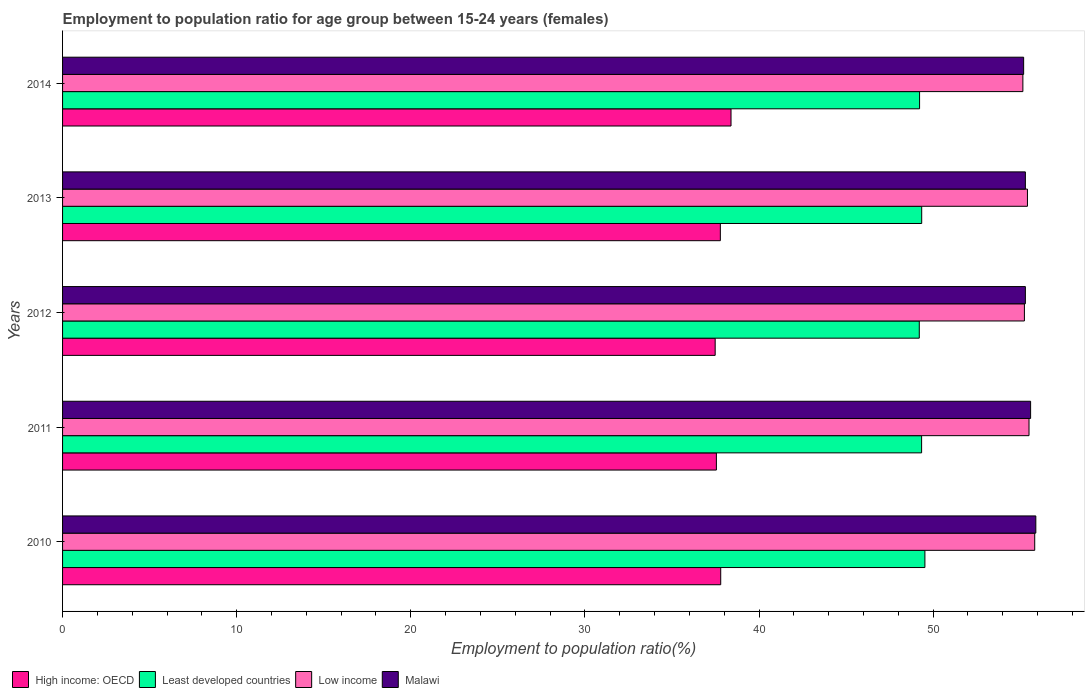How many groups of bars are there?
Ensure brevity in your answer.  5. Are the number of bars per tick equal to the number of legend labels?
Provide a short and direct response. Yes. How many bars are there on the 2nd tick from the top?
Your answer should be very brief. 4. How many bars are there on the 5th tick from the bottom?
Provide a succinct answer. 4. In how many cases, is the number of bars for a given year not equal to the number of legend labels?
Your answer should be very brief. 0. What is the employment to population ratio in Low income in 2013?
Provide a short and direct response. 55.42. Across all years, what is the maximum employment to population ratio in High income: OECD?
Your response must be concise. 38.39. Across all years, what is the minimum employment to population ratio in High income: OECD?
Ensure brevity in your answer.  37.48. In which year was the employment to population ratio in Low income maximum?
Your answer should be very brief. 2010. What is the total employment to population ratio in Low income in the graph?
Your answer should be compact. 277.16. What is the difference between the employment to population ratio in Least developed countries in 2011 and that in 2014?
Give a very brief answer. 0.12. What is the difference between the employment to population ratio in Low income in 2014 and the employment to population ratio in Least developed countries in 2012?
Your answer should be compact. 5.95. What is the average employment to population ratio in Low income per year?
Provide a succinct answer. 55.43. In the year 2014, what is the difference between the employment to population ratio in High income: OECD and employment to population ratio in Malawi?
Offer a terse response. -16.81. In how many years, is the employment to population ratio in Least developed countries greater than 24 %?
Give a very brief answer. 5. What is the ratio of the employment to population ratio in Low income in 2012 to that in 2013?
Offer a terse response. 1. Is the employment to population ratio in Malawi in 2013 less than that in 2014?
Your answer should be very brief. No. What is the difference between the highest and the second highest employment to population ratio in High income: OECD?
Offer a very short reply. 0.59. What is the difference between the highest and the lowest employment to population ratio in Least developed countries?
Offer a terse response. 0.32. Is the sum of the employment to population ratio in Low income in 2012 and 2013 greater than the maximum employment to population ratio in Malawi across all years?
Provide a short and direct response. Yes. Is it the case that in every year, the sum of the employment to population ratio in Least developed countries and employment to population ratio in High income: OECD is greater than the sum of employment to population ratio in Low income and employment to population ratio in Malawi?
Your answer should be compact. No. What does the 4th bar from the top in 2010 represents?
Keep it short and to the point. High income: OECD. What does the 4th bar from the bottom in 2013 represents?
Offer a very short reply. Malawi. Is it the case that in every year, the sum of the employment to population ratio in High income: OECD and employment to population ratio in Low income is greater than the employment to population ratio in Malawi?
Your answer should be compact. Yes. Are all the bars in the graph horizontal?
Your answer should be compact. Yes. What is the difference between two consecutive major ticks on the X-axis?
Your answer should be very brief. 10. Does the graph contain any zero values?
Ensure brevity in your answer.  No. Does the graph contain grids?
Provide a short and direct response. No. Where does the legend appear in the graph?
Make the answer very short. Bottom left. How are the legend labels stacked?
Keep it short and to the point. Horizontal. What is the title of the graph?
Your response must be concise. Employment to population ratio for age group between 15-24 years (females). What is the Employment to population ratio(%) in High income: OECD in 2010?
Ensure brevity in your answer.  37.8. What is the Employment to population ratio(%) in Least developed countries in 2010?
Give a very brief answer. 49.53. What is the Employment to population ratio(%) in Low income in 2010?
Offer a very short reply. 55.84. What is the Employment to population ratio(%) of Malawi in 2010?
Give a very brief answer. 55.9. What is the Employment to population ratio(%) in High income: OECD in 2011?
Provide a short and direct response. 37.55. What is the Employment to population ratio(%) in Least developed countries in 2011?
Your answer should be very brief. 49.34. What is the Employment to population ratio(%) in Low income in 2011?
Your response must be concise. 55.51. What is the Employment to population ratio(%) of Malawi in 2011?
Keep it short and to the point. 55.6. What is the Employment to population ratio(%) in High income: OECD in 2012?
Your answer should be very brief. 37.48. What is the Employment to population ratio(%) of Least developed countries in 2012?
Your response must be concise. 49.21. What is the Employment to population ratio(%) in Low income in 2012?
Offer a terse response. 55.24. What is the Employment to population ratio(%) of Malawi in 2012?
Provide a short and direct response. 55.3. What is the Employment to population ratio(%) in High income: OECD in 2013?
Your answer should be very brief. 37.78. What is the Employment to population ratio(%) in Least developed countries in 2013?
Give a very brief answer. 49.35. What is the Employment to population ratio(%) in Low income in 2013?
Provide a succinct answer. 55.42. What is the Employment to population ratio(%) of Malawi in 2013?
Offer a very short reply. 55.3. What is the Employment to population ratio(%) in High income: OECD in 2014?
Offer a very short reply. 38.39. What is the Employment to population ratio(%) of Least developed countries in 2014?
Offer a terse response. 49.22. What is the Employment to population ratio(%) in Low income in 2014?
Ensure brevity in your answer.  55.16. What is the Employment to population ratio(%) of Malawi in 2014?
Ensure brevity in your answer.  55.2. Across all years, what is the maximum Employment to population ratio(%) in High income: OECD?
Provide a short and direct response. 38.39. Across all years, what is the maximum Employment to population ratio(%) of Least developed countries?
Make the answer very short. 49.53. Across all years, what is the maximum Employment to population ratio(%) in Low income?
Make the answer very short. 55.84. Across all years, what is the maximum Employment to population ratio(%) of Malawi?
Make the answer very short. 55.9. Across all years, what is the minimum Employment to population ratio(%) in High income: OECD?
Offer a very short reply. 37.48. Across all years, what is the minimum Employment to population ratio(%) in Least developed countries?
Ensure brevity in your answer.  49.21. Across all years, what is the minimum Employment to population ratio(%) of Low income?
Offer a very short reply. 55.16. Across all years, what is the minimum Employment to population ratio(%) in Malawi?
Provide a succinct answer. 55.2. What is the total Employment to population ratio(%) of High income: OECD in the graph?
Offer a very short reply. 189.01. What is the total Employment to population ratio(%) of Least developed countries in the graph?
Offer a terse response. 246.64. What is the total Employment to population ratio(%) in Low income in the graph?
Ensure brevity in your answer.  277.16. What is the total Employment to population ratio(%) in Malawi in the graph?
Your answer should be compact. 277.3. What is the difference between the Employment to population ratio(%) of High income: OECD in 2010 and that in 2011?
Make the answer very short. 0.25. What is the difference between the Employment to population ratio(%) of Least developed countries in 2010 and that in 2011?
Offer a terse response. 0.19. What is the difference between the Employment to population ratio(%) in Low income in 2010 and that in 2011?
Give a very brief answer. 0.33. What is the difference between the Employment to population ratio(%) of Malawi in 2010 and that in 2011?
Provide a short and direct response. 0.3. What is the difference between the Employment to population ratio(%) in High income: OECD in 2010 and that in 2012?
Your response must be concise. 0.32. What is the difference between the Employment to population ratio(%) in Least developed countries in 2010 and that in 2012?
Give a very brief answer. 0.32. What is the difference between the Employment to population ratio(%) of Low income in 2010 and that in 2012?
Your answer should be compact. 0.59. What is the difference between the Employment to population ratio(%) of Malawi in 2010 and that in 2012?
Provide a short and direct response. 0.6. What is the difference between the Employment to population ratio(%) in High income: OECD in 2010 and that in 2013?
Make the answer very short. 0.02. What is the difference between the Employment to population ratio(%) of Least developed countries in 2010 and that in 2013?
Give a very brief answer. 0.18. What is the difference between the Employment to population ratio(%) in Low income in 2010 and that in 2013?
Your response must be concise. 0.42. What is the difference between the Employment to population ratio(%) of Malawi in 2010 and that in 2013?
Your answer should be compact. 0.6. What is the difference between the Employment to population ratio(%) of High income: OECD in 2010 and that in 2014?
Your response must be concise. -0.59. What is the difference between the Employment to population ratio(%) in Least developed countries in 2010 and that in 2014?
Your response must be concise. 0.31. What is the difference between the Employment to population ratio(%) in Low income in 2010 and that in 2014?
Provide a succinct answer. 0.68. What is the difference between the Employment to population ratio(%) of High income: OECD in 2011 and that in 2012?
Your response must be concise. 0.07. What is the difference between the Employment to population ratio(%) in Least developed countries in 2011 and that in 2012?
Your answer should be very brief. 0.13. What is the difference between the Employment to population ratio(%) of Low income in 2011 and that in 2012?
Your answer should be compact. 0.27. What is the difference between the Employment to population ratio(%) of Malawi in 2011 and that in 2012?
Offer a very short reply. 0.3. What is the difference between the Employment to population ratio(%) in High income: OECD in 2011 and that in 2013?
Ensure brevity in your answer.  -0.23. What is the difference between the Employment to population ratio(%) of Least developed countries in 2011 and that in 2013?
Provide a succinct answer. -0.01. What is the difference between the Employment to population ratio(%) of Low income in 2011 and that in 2013?
Provide a short and direct response. 0.09. What is the difference between the Employment to population ratio(%) in Malawi in 2011 and that in 2013?
Give a very brief answer. 0.3. What is the difference between the Employment to population ratio(%) of High income: OECD in 2011 and that in 2014?
Provide a short and direct response. -0.84. What is the difference between the Employment to population ratio(%) in Least developed countries in 2011 and that in 2014?
Your answer should be very brief. 0.12. What is the difference between the Employment to population ratio(%) of Low income in 2011 and that in 2014?
Ensure brevity in your answer.  0.35. What is the difference between the Employment to population ratio(%) in High income: OECD in 2012 and that in 2013?
Provide a succinct answer. -0.3. What is the difference between the Employment to population ratio(%) of Least developed countries in 2012 and that in 2013?
Keep it short and to the point. -0.14. What is the difference between the Employment to population ratio(%) of Low income in 2012 and that in 2013?
Make the answer very short. -0.18. What is the difference between the Employment to population ratio(%) in Malawi in 2012 and that in 2013?
Provide a succinct answer. 0. What is the difference between the Employment to population ratio(%) in High income: OECD in 2012 and that in 2014?
Ensure brevity in your answer.  -0.91. What is the difference between the Employment to population ratio(%) of Least developed countries in 2012 and that in 2014?
Make the answer very short. -0.02. What is the difference between the Employment to population ratio(%) of Low income in 2012 and that in 2014?
Your answer should be very brief. 0.09. What is the difference between the Employment to population ratio(%) in High income: OECD in 2013 and that in 2014?
Ensure brevity in your answer.  -0.61. What is the difference between the Employment to population ratio(%) of Least developed countries in 2013 and that in 2014?
Keep it short and to the point. 0.12. What is the difference between the Employment to population ratio(%) in Low income in 2013 and that in 2014?
Offer a terse response. 0.26. What is the difference between the Employment to population ratio(%) of High income: OECD in 2010 and the Employment to population ratio(%) of Least developed countries in 2011?
Offer a very short reply. -11.54. What is the difference between the Employment to population ratio(%) in High income: OECD in 2010 and the Employment to population ratio(%) in Low income in 2011?
Your answer should be compact. -17.71. What is the difference between the Employment to population ratio(%) of High income: OECD in 2010 and the Employment to population ratio(%) of Malawi in 2011?
Your answer should be very brief. -17.8. What is the difference between the Employment to population ratio(%) of Least developed countries in 2010 and the Employment to population ratio(%) of Low income in 2011?
Offer a terse response. -5.98. What is the difference between the Employment to population ratio(%) in Least developed countries in 2010 and the Employment to population ratio(%) in Malawi in 2011?
Provide a short and direct response. -6.07. What is the difference between the Employment to population ratio(%) in Low income in 2010 and the Employment to population ratio(%) in Malawi in 2011?
Give a very brief answer. 0.24. What is the difference between the Employment to population ratio(%) in High income: OECD in 2010 and the Employment to population ratio(%) in Least developed countries in 2012?
Ensure brevity in your answer.  -11.4. What is the difference between the Employment to population ratio(%) of High income: OECD in 2010 and the Employment to population ratio(%) of Low income in 2012?
Your response must be concise. -17.44. What is the difference between the Employment to population ratio(%) in High income: OECD in 2010 and the Employment to population ratio(%) in Malawi in 2012?
Offer a terse response. -17.5. What is the difference between the Employment to population ratio(%) of Least developed countries in 2010 and the Employment to population ratio(%) of Low income in 2012?
Offer a terse response. -5.71. What is the difference between the Employment to population ratio(%) in Least developed countries in 2010 and the Employment to population ratio(%) in Malawi in 2012?
Offer a very short reply. -5.77. What is the difference between the Employment to population ratio(%) of Low income in 2010 and the Employment to population ratio(%) of Malawi in 2012?
Provide a succinct answer. 0.54. What is the difference between the Employment to population ratio(%) of High income: OECD in 2010 and the Employment to population ratio(%) of Least developed countries in 2013?
Ensure brevity in your answer.  -11.54. What is the difference between the Employment to population ratio(%) in High income: OECD in 2010 and the Employment to population ratio(%) in Low income in 2013?
Provide a short and direct response. -17.62. What is the difference between the Employment to population ratio(%) in High income: OECD in 2010 and the Employment to population ratio(%) in Malawi in 2013?
Provide a short and direct response. -17.5. What is the difference between the Employment to population ratio(%) in Least developed countries in 2010 and the Employment to population ratio(%) in Low income in 2013?
Your response must be concise. -5.89. What is the difference between the Employment to population ratio(%) in Least developed countries in 2010 and the Employment to population ratio(%) in Malawi in 2013?
Offer a very short reply. -5.77. What is the difference between the Employment to population ratio(%) of Low income in 2010 and the Employment to population ratio(%) of Malawi in 2013?
Make the answer very short. 0.54. What is the difference between the Employment to population ratio(%) of High income: OECD in 2010 and the Employment to population ratio(%) of Least developed countries in 2014?
Make the answer very short. -11.42. What is the difference between the Employment to population ratio(%) in High income: OECD in 2010 and the Employment to population ratio(%) in Low income in 2014?
Ensure brevity in your answer.  -17.35. What is the difference between the Employment to population ratio(%) of High income: OECD in 2010 and the Employment to population ratio(%) of Malawi in 2014?
Offer a terse response. -17.4. What is the difference between the Employment to population ratio(%) of Least developed countries in 2010 and the Employment to population ratio(%) of Low income in 2014?
Provide a succinct answer. -5.63. What is the difference between the Employment to population ratio(%) of Least developed countries in 2010 and the Employment to population ratio(%) of Malawi in 2014?
Offer a terse response. -5.67. What is the difference between the Employment to population ratio(%) in Low income in 2010 and the Employment to population ratio(%) in Malawi in 2014?
Your answer should be compact. 0.64. What is the difference between the Employment to population ratio(%) of High income: OECD in 2011 and the Employment to population ratio(%) of Least developed countries in 2012?
Give a very brief answer. -11.65. What is the difference between the Employment to population ratio(%) of High income: OECD in 2011 and the Employment to population ratio(%) of Low income in 2012?
Offer a very short reply. -17.69. What is the difference between the Employment to population ratio(%) of High income: OECD in 2011 and the Employment to population ratio(%) of Malawi in 2012?
Your answer should be very brief. -17.75. What is the difference between the Employment to population ratio(%) of Least developed countries in 2011 and the Employment to population ratio(%) of Low income in 2012?
Ensure brevity in your answer.  -5.9. What is the difference between the Employment to population ratio(%) of Least developed countries in 2011 and the Employment to population ratio(%) of Malawi in 2012?
Offer a very short reply. -5.96. What is the difference between the Employment to population ratio(%) in Low income in 2011 and the Employment to population ratio(%) in Malawi in 2012?
Keep it short and to the point. 0.21. What is the difference between the Employment to population ratio(%) of High income: OECD in 2011 and the Employment to population ratio(%) of Least developed countries in 2013?
Provide a succinct answer. -11.79. What is the difference between the Employment to population ratio(%) of High income: OECD in 2011 and the Employment to population ratio(%) of Low income in 2013?
Your answer should be compact. -17.87. What is the difference between the Employment to population ratio(%) of High income: OECD in 2011 and the Employment to population ratio(%) of Malawi in 2013?
Offer a very short reply. -17.75. What is the difference between the Employment to population ratio(%) in Least developed countries in 2011 and the Employment to population ratio(%) in Low income in 2013?
Offer a very short reply. -6.08. What is the difference between the Employment to population ratio(%) of Least developed countries in 2011 and the Employment to population ratio(%) of Malawi in 2013?
Your response must be concise. -5.96. What is the difference between the Employment to population ratio(%) of Low income in 2011 and the Employment to population ratio(%) of Malawi in 2013?
Your answer should be compact. 0.21. What is the difference between the Employment to population ratio(%) of High income: OECD in 2011 and the Employment to population ratio(%) of Least developed countries in 2014?
Offer a very short reply. -11.67. What is the difference between the Employment to population ratio(%) in High income: OECD in 2011 and the Employment to population ratio(%) in Low income in 2014?
Provide a short and direct response. -17.6. What is the difference between the Employment to population ratio(%) of High income: OECD in 2011 and the Employment to population ratio(%) of Malawi in 2014?
Your answer should be very brief. -17.65. What is the difference between the Employment to population ratio(%) in Least developed countries in 2011 and the Employment to population ratio(%) in Low income in 2014?
Offer a very short reply. -5.82. What is the difference between the Employment to population ratio(%) in Least developed countries in 2011 and the Employment to population ratio(%) in Malawi in 2014?
Provide a short and direct response. -5.86. What is the difference between the Employment to population ratio(%) in Low income in 2011 and the Employment to population ratio(%) in Malawi in 2014?
Provide a succinct answer. 0.31. What is the difference between the Employment to population ratio(%) in High income: OECD in 2012 and the Employment to population ratio(%) in Least developed countries in 2013?
Your answer should be very brief. -11.86. What is the difference between the Employment to population ratio(%) in High income: OECD in 2012 and the Employment to population ratio(%) in Low income in 2013?
Ensure brevity in your answer.  -17.94. What is the difference between the Employment to population ratio(%) of High income: OECD in 2012 and the Employment to population ratio(%) of Malawi in 2013?
Keep it short and to the point. -17.82. What is the difference between the Employment to population ratio(%) in Least developed countries in 2012 and the Employment to population ratio(%) in Low income in 2013?
Provide a succinct answer. -6.21. What is the difference between the Employment to population ratio(%) in Least developed countries in 2012 and the Employment to population ratio(%) in Malawi in 2013?
Your response must be concise. -6.09. What is the difference between the Employment to population ratio(%) of Low income in 2012 and the Employment to population ratio(%) of Malawi in 2013?
Give a very brief answer. -0.06. What is the difference between the Employment to population ratio(%) of High income: OECD in 2012 and the Employment to population ratio(%) of Least developed countries in 2014?
Provide a short and direct response. -11.74. What is the difference between the Employment to population ratio(%) of High income: OECD in 2012 and the Employment to population ratio(%) of Low income in 2014?
Give a very brief answer. -17.67. What is the difference between the Employment to population ratio(%) in High income: OECD in 2012 and the Employment to population ratio(%) in Malawi in 2014?
Give a very brief answer. -17.72. What is the difference between the Employment to population ratio(%) of Least developed countries in 2012 and the Employment to population ratio(%) of Low income in 2014?
Your answer should be very brief. -5.95. What is the difference between the Employment to population ratio(%) in Least developed countries in 2012 and the Employment to population ratio(%) in Malawi in 2014?
Provide a succinct answer. -5.99. What is the difference between the Employment to population ratio(%) in Low income in 2012 and the Employment to population ratio(%) in Malawi in 2014?
Provide a short and direct response. 0.04. What is the difference between the Employment to population ratio(%) of High income: OECD in 2013 and the Employment to population ratio(%) of Least developed countries in 2014?
Give a very brief answer. -11.44. What is the difference between the Employment to population ratio(%) of High income: OECD in 2013 and the Employment to population ratio(%) of Low income in 2014?
Make the answer very short. -17.38. What is the difference between the Employment to population ratio(%) in High income: OECD in 2013 and the Employment to population ratio(%) in Malawi in 2014?
Keep it short and to the point. -17.42. What is the difference between the Employment to population ratio(%) of Least developed countries in 2013 and the Employment to population ratio(%) of Low income in 2014?
Make the answer very short. -5.81. What is the difference between the Employment to population ratio(%) of Least developed countries in 2013 and the Employment to population ratio(%) of Malawi in 2014?
Your response must be concise. -5.85. What is the difference between the Employment to population ratio(%) of Low income in 2013 and the Employment to population ratio(%) of Malawi in 2014?
Your answer should be very brief. 0.22. What is the average Employment to population ratio(%) in High income: OECD per year?
Your answer should be compact. 37.8. What is the average Employment to population ratio(%) of Least developed countries per year?
Make the answer very short. 49.33. What is the average Employment to population ratio(%) in Low income per year?
Your response must be concise. 55.43. What is the average Employment to population ratio(%) of Malawi per year?
Ensure brevity in your answer.  55.46. In the year 2010, what is the difference between the Employment to population ratio(%) of High income: OECD and Employment to population ratio(%) of Least developed countries?
Offer a terse response. -11.73. In the year 2010, what is the difference between the Employment to population ratio(%) in High income: OECD and Employment to population ratio(%) in Low income?
Provide a succinct answer. -18.03. In the year 2010, what is the difference between the Employment to population ratio(%) of High income: OECD and Employment to population ratio(%) of Malawi?
Provide a short and direct response. -18.1. In the year 2010, what is the difference between the Employment to population ratio(%) in Least developed countries and Employment to population ratio(%) in Low income?
Make the answer very short. -6.31. In the year 2010, what is the difference between the Employment to population ratio(%) of Least developed countries and Employment to population ratio(%) of Malawi?
Your answer should be compact. -6.37. In the year 2010, what is the difference between the Employment to population ratio(%) in Low income and Employment to population ratio(%) in Malawi?
Make the answer very short. -0.06. In the year 2011, what is the difference between the Employment to population ratio(%) of High income: OECD and Employment to population ratio(%) of Least developed countries?
Give a very brief answer. -11.79. In the year 2011, what is the difference between the Employment to population ratio(%) of High income: OECD and Employment to population ratio(%) of Low income?
Ensure brevity in your answer.  -17.96. In the year 2011, what is the difference between the Employment to population ratio(%) of High income: OECD and Employment to population ratio(%) of Malawi?
Your answer should be compact. -18.05. In the year 2011, what is the difference between the Employment to population ratio(%) of Least developed countries and Employment to population ratio(%) of Low income?
Your answer should be very brief. -6.17. In the year 2011, what is the difference between the Employment to population ratio(%) in Least developed countries and Employment to population ratio(%) in Malawi?
Keep it short and to the point. -6.26. In the year 2011, what is the difference between the Employment to population ratio(%) of Low income and Employment to population ratio(%) of Malawi?
Your response must be concise. -0.09. In the year 2012, what is the difference between the Employment to population ratio(%) of High income: OECD and Employment to population ratio(%) of Least developed countries?
Offer a very short reply. -11.72. In the year 2012, what is the difference between the Employment to population ratio(%) of High income: OECD and Employment to population ratio(%) of Low income?
Provide a short and direct response. -17.76. In the year 2012, what is the difference between the Employment to population ratio(%) of High income: OECD and Employment to population ratio(%) of Malawi?
Your response must be concise. -17.82. In the year 2012, what is the difference between the Employment to population ratio(%) of Least developed countries and Employment to population ratio(%) of Low income?
Offer a very short reply. -6.04. In the year 2012, what is the difference between the Employment to population ratio(%) in Least developed countries and Employment to population ratio(%) in Malawi?
Offer a terse response. -6.09. In the year 2012, what is the difference between the Employment to population ratio(%) in Low income and Employment to population ratio(%) in Malawi?
Provide a succinct answer. -0.06. In the year 2013, what is the difference between the Employment to population ratio(%) in High income: OECD and Employment to population ratio(%) in Least developed countries?
Give a very brief answer. -11.57. In the year 2013, what is the difference between the Employment to population ratio(%) in High income: OECD and Employment to population ratio(%) in Low income?
Make the answer very short. -17.64. In the year 2013, what is the difference between the Employment to population ratio(%) of High income: OECD and Employment to population ratio(%) of Malawi?
Ensure brevity in your answer.  -17.52. In the year 2013, what is the difference between the Employment to population ratio(%) of Least developed countries and Employment to population ratio(%) of Low income?
Provide a succinct answer. -6.07. In the year 2013, what is the difference between the Employment to population ratio(%) of Least developed countries and Employment to population ratio(%) of Malawi?
Provide a short and direct response. -5.95. In the year 2013, what is the difference between the Employment to population ratio(%) in Low income and Employment to population ratio(%) in Malawi?
Make the answer very short. 0.12. In the year 2014, what is the difference between the Employment to population ratio(%) in High income: OECD and Employment to population ratio(%) in Least developed countries?
Your response must be concise. -10.83. In the year 2014, what is the difference between the Employment to population ratio(%) of High income: OECD and Employment to population ratio(%) of Low income?
Your answer should be compact. -16.76. In the year 2014, what is the difference between the Employment to population ratio(%) in High income: OECD and Employment to population ratio(%) in Malawi?
Offer a very short reply. -16.81. In the year 2014, what is the difference between the Employment to population ratio(%) of Least developed countries and Employment to population ratio(%) of Low income?
Offer a very short reply. -5.93. In the year 2014, what is the difference between the Employment to population ratio(%) in Least developed countries and Employment to population ratio(%) in Malawi?
Offer a very short reply. -5.98. In the year 2014, what is the difference between the Employment to population ratio(%) in Low income and Employment to population ratio(%) in Malawi?
Keep it short and to the point. -0.04. What is the ratio of the Employment to population ratio(%) in High income: OECD in 2010 to that in 2011?
Offer a terse response. 1.01. What is the ratio of the Employment to population ratio(%) of Low income in 2010 to that in 2011?
Your answer should be compact. 1.01. What is the ratio of the Employment to population ratio(%) in Malawi in 2010 to that in 2011?
Provide a succinct answer. 1.01. What is the ratio of the Employment to population ratio(%) in High income: OECD in 2010 to that in 2012?
Your response must be concise. 1.01. What is the ratio of the Employment to population ratio(%) in Least developed countries in 2010 to that in 2012?
Provide a short and direct response. 1.01. What is the ratio of the Employment to population ratio(%) of Low income in 2010 to that in 2012?
Your answer should be very brief. 1.01. What is the ratio of the Employment to population ratio(%) in Malawi in 2010 to that in 2012?
Ensure brevity in your answer.  1.01. What is the ratio of the Employment to population ratio(%) in Low income in 2010 to that in 2013?
Provide a succinct answer. 1.01. What is the ratio of the Employment to population ratio(%) of Malawi in 2010 to that in 2013?
Offer a very short reply. 1.01. What is the ratio of the Employment to population ratio(%) in High income: OECD in 2010 to that in 2014?
Offer a very short reply. 0.98. What is the ratio of the Employment to population ratio(%) of Least developed countries in 2010 to that in 2014?
Give a very brief answer. 1.01. What is the ratio of the Employment to population ratio(%) in Low income in 2010 to that in 2014?
Provide a succinct answer. 1.01. What is the ratio of the Employment to population ratio(%) in Malawi in 2010 to that in 2014?
Your response must be concise. 1.01. What is the ratio of the Employment to population ratio(%) of High income: OECD in 2011 to that in 2012?
Offer a very short reply. 1. What is the ratio of the Employment to population ratio(%) in Least developed countries in 2011 to that in 2012?
Keep it short and to the point. 1. What is the ratio of the Employment to population ratio(%) of Low income in 2011 to that in 2012?
Your answer should be very brief. 1. What is the ratio of the Employment to population ratio(%) in Malawi in 2011 to that in 2012?
Your response must be concise. 1.01. What is the ratio of the Employment to population ratio(%) of High income: OECD in 2011 to that in 2013?
Provide a succinct answer. 0.99. What is the ratio of the Employment to population ratio(%) of Malawi in 2011 to that in 2013?
Provide a succinct answer. 1.01. What is the ratio of the Employment to population ratio(%) of High income: OECD in 2011 to that in 2014?
Keep it short and to the point. 0.98. What is the ratio of the Employment to population ratio(%) of Least developed countries in 2011 to that in 2014?
Offer a very short reply. 1. What is the ratio of the Employment to population ratio(%) of Low income in 2011 to that in 2014?
Give a very brief answer. 1.01. What is the ratio of the Employment to population ratio(%) of High income: OECD in 2012 to that in 2013?
Ensure brevity in your answer.  0.99. What is the ratio of the Employment to population ratio(%) in Least developed countries in 2012 to that in 2013?
Your answer should be very brief. 1. What is the ratio of the Employment to population ratio(%) of High income: OECD in 2012 to that in 2014?
Offer a terse response. 0.98. What is the ratio of the Employment to population ratio(%) of Least developed countries in 2012 to that in 2014?
Make the answer very short. 1. What is the ratio of the Employment to population ratio(%) in Low income in 2012 to that in 2014?
Keep it short and to the point. 1. What is the ratio of the Employment to population ratio(%) of High income: OECD in 2013 to that in 2014?
Your answer should be very brief. 0.98. What is the ratio of the Employment to population ratio(%) of Low income in 2013 to that in 2014?
Make the answer very short. 1. What is the difference between the highest and the second highest Employment to population ratio(%) in High income: OECD?
Your response must be concise. 0.59. What is the difference between the highest and the second highest Employment to population ratio(%) in Least developed countries?
Give a very brief answer. 0.18. What is the difference between the highest and the second highest Employment to population ratio(%) in Low income?
Offer a terse response. 0.33. What is the difference between the highest and the lowest Employment to population ratio(%) of High income: OECD?
Your answer should be compact. 0.91. What is the difference between the highest and the lowest Employment to population ratio(%) in Least developed countries?
Keep it short and to the point. 0.32. What is the difference between the highest and the lowest Employment to population ratio(%) of Low income?
Offer a very short reply. 0.68. What is the difference between the highest and the lowest Employment to population ratio(%) of Malawi?
Your answer should be compact. 0.7. 